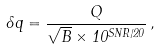Convert formula to latex. <formula><loc_0><loc_0><loc_500><loc_500>\delta q = \frac { Q } { \sqrt { B } \times 1 0 ^ { S N R / 2 0 } } \, ,</formula> 